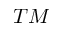<formula> <loc_0><loc_0><loc_500><loc_500>T M</formula> 